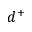Convert formula to latex. <formula><loc_0><loc_0><loc_500><loc_500>d ^ { + }</formula> 